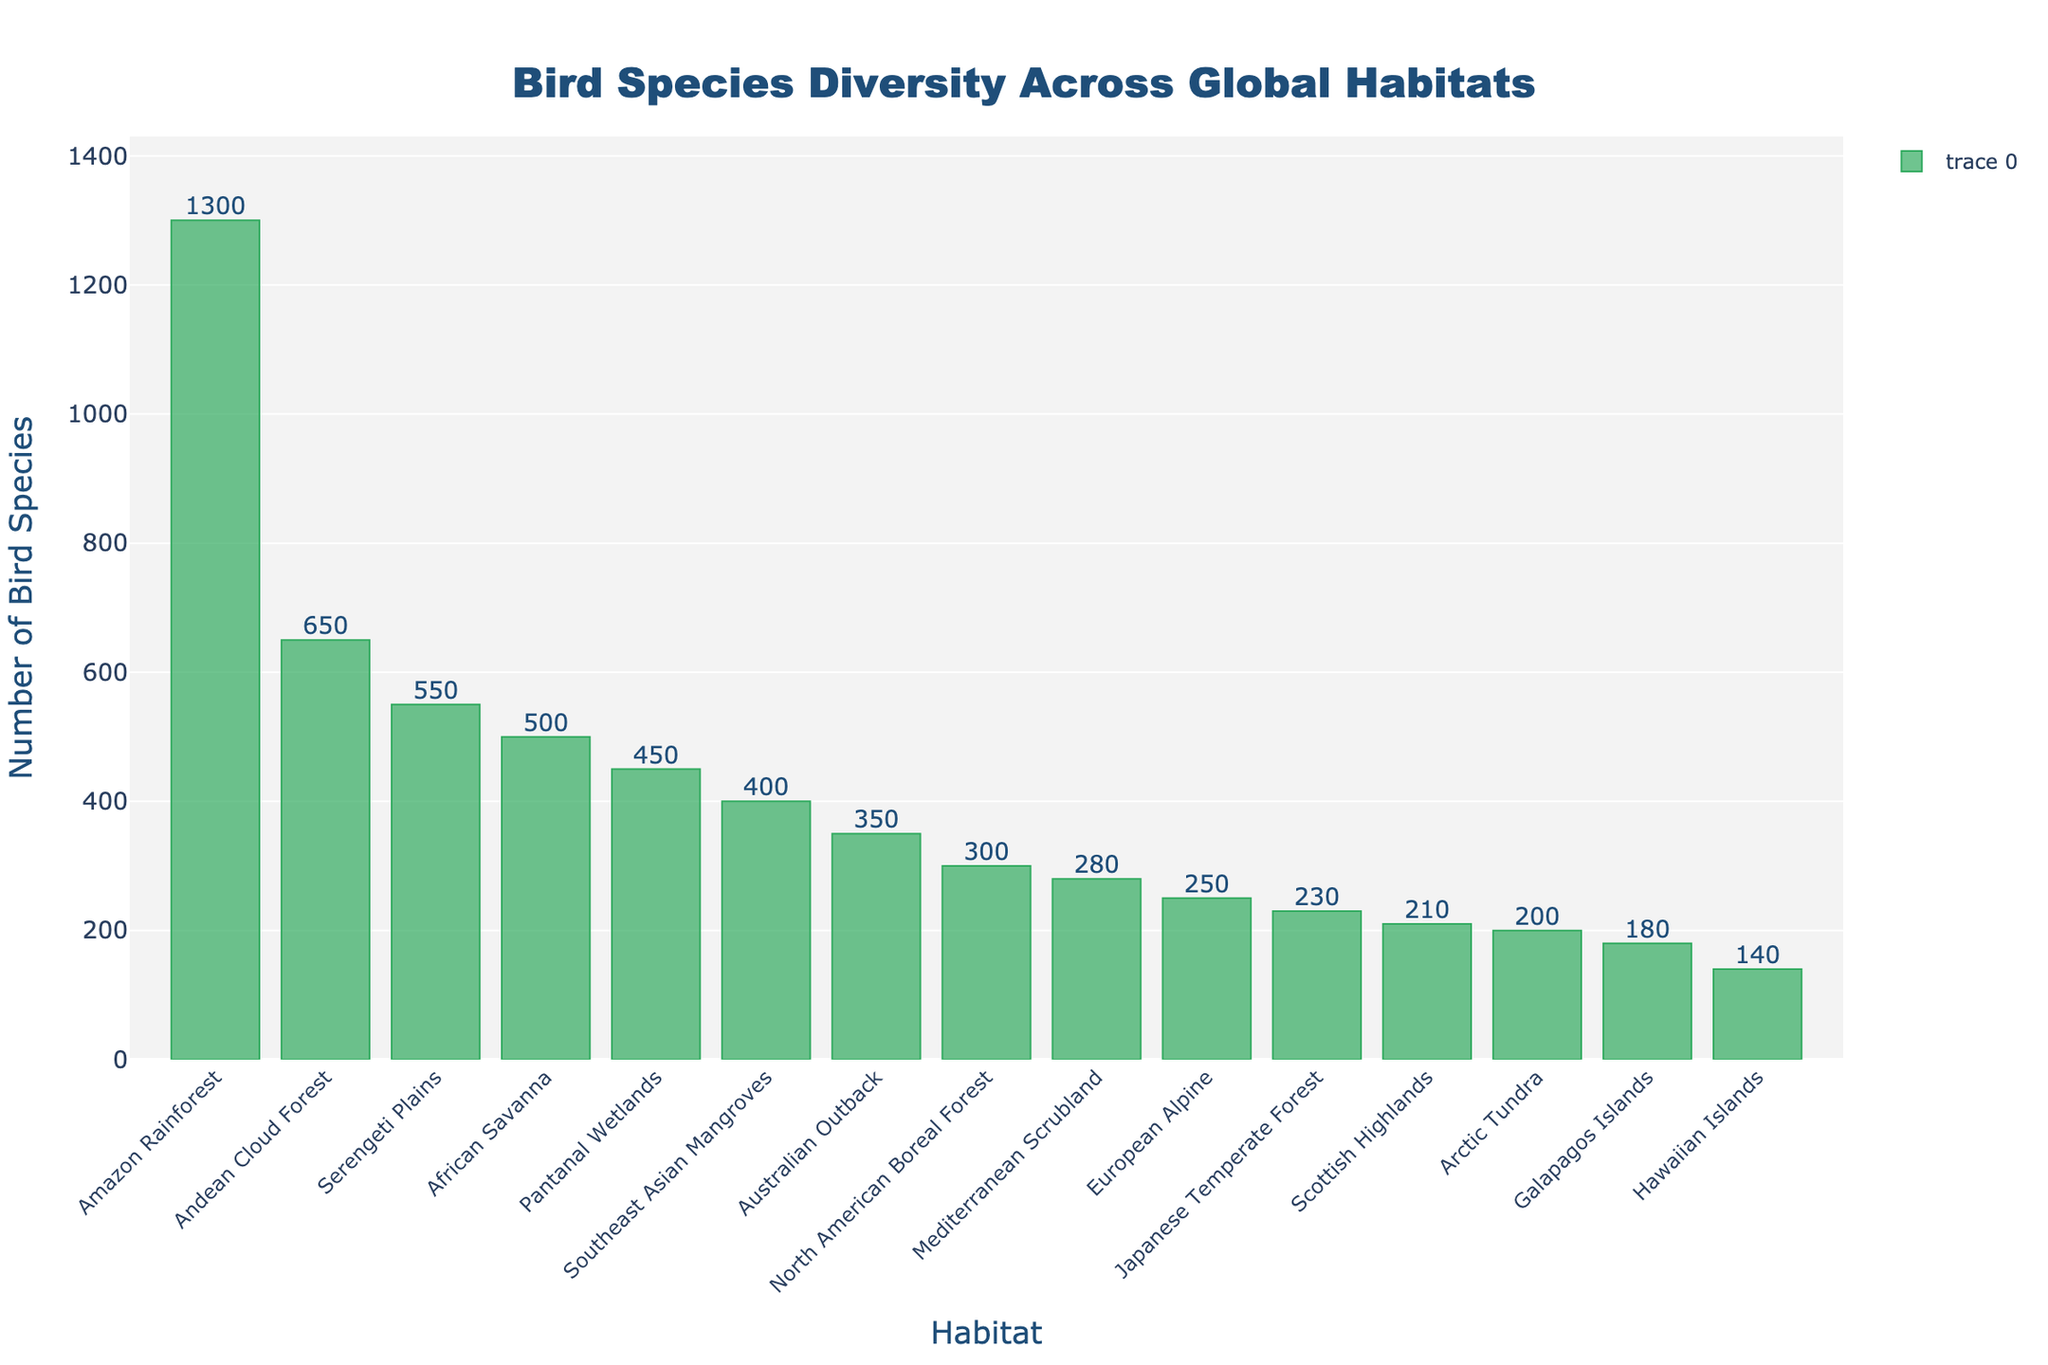Which habitat has the highest bird species count? According to the longest bar in the chart, the Amazon Rainforest has the highest bird species count.
Answer: Amazon Rainforest Which habitat has the lowest bird species count? According to the shortest bar in the chart, the Hawaiian Islands have the lowest bird species count.
Answer: Hawaiian Islands How many more bird species are there in the Amazon Rainforest compared to the Arctic Tundra? To find the difference, subtract the bird species count of the Arctic Tundra (200) from that of the Amazon Rainforest (1300). 1300 - 200 = 1100
Answer: 1100 What is the combined bird species count for the African Savanna and Serengeti Plains? To find the sum, add the bird species count of the African Savanna (500) to that of the Serengeti Plains (550). 500 + 550 = 1050
Answer: 1050 Which habitat has a bird species count closest to the mean count of all habitats? First, calculate the mean by summing all the bird species counts and dividing by the number of habitats. The total count is 5290, and there are 15 habitats. The mean is 5290 / 15 ≈ 352.67. The Australian Outback, with a count of 350, is closest to this mean.
Answer: Australian Outback Are there more bird species in the Andean Cloud Forest or the North American Boreal Forest? The bar for the Andean Cloud Forest is taller than the bar for the North American Boreal Forest. The Andean Cloud Forest has 650 species, while the North American Boreal Forest has 300. 650 > 300
Answer: Andean Cloud Forest What's the average bird species count for the habitats in the chart? Sum all the bird species counts and divide by the number of habitats. The total count is 5290, and there are 15 habitats. 5290 / 15 ≈ 352.67
Answer: 352.67 What's the sum of bird species counts for habitats in the Southern Hemisphere (Amazon Rainforest, Australian Outback, Andean Cloud Forest, Pantanal Wetlands)? Add together the counts: Amazon Rainforest (1300), Australian Outback (350), Andean Cloud Forest (650), and Pantanal Wetlands (450). 1300 + 350 + 650 + 450 = 2750
Answer: 2750 Which habitat has approximately half the bird species count of the Amazon Rainforest? Half of the bird species count of the Amazon Rainforest (1300) is 1300 / 2 = 650. The Andean Cloud Forest has exactly 650 species, which is approximately half.
Answer: Andean Cloud Forest How does the bird species count in the North American Boreal Forest compare to the Mediterranean Scrubland? The bird species count in the North American Boreal Forest (300) is slightly higher than that in the Mediterranean Scrubland (280).
Answer: North American Boreal Forest 